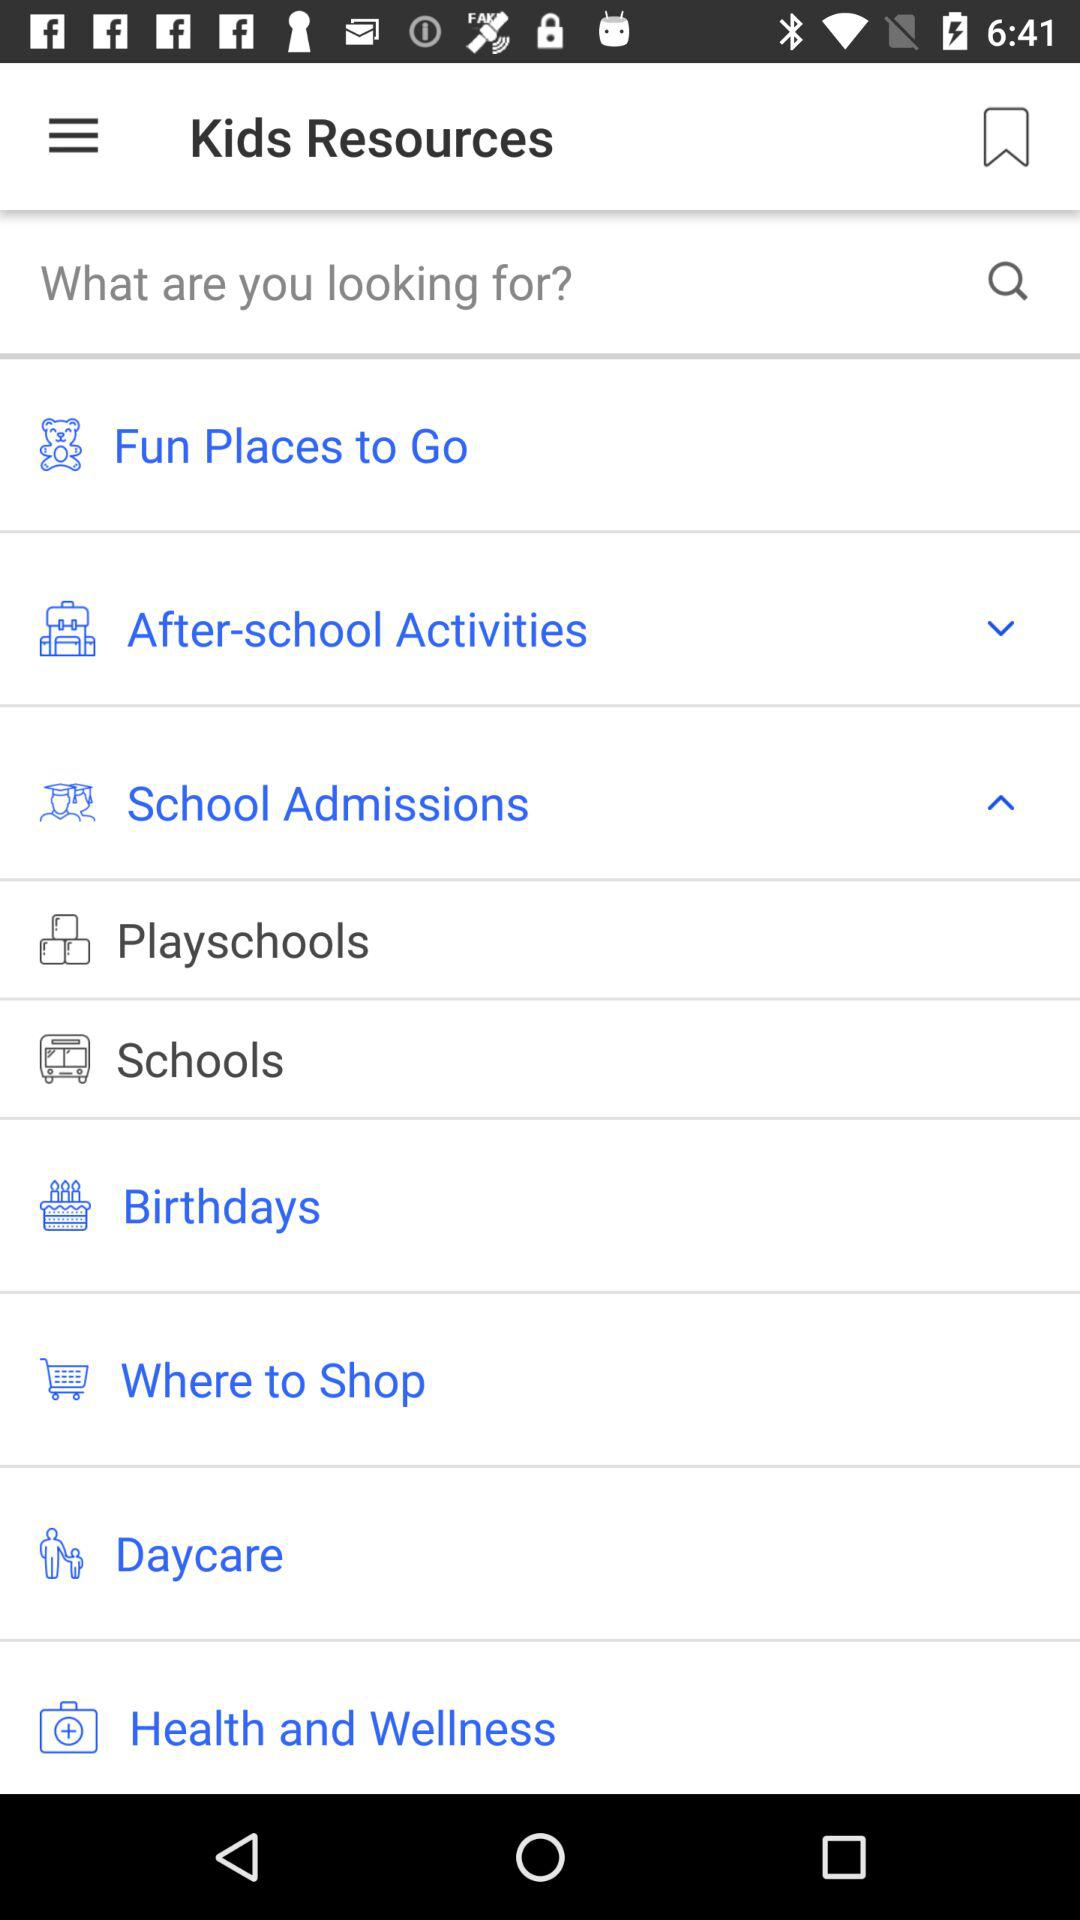Which drop-down menu has been expanded? The drop-down menu that has been expanded is "School Admissions". 